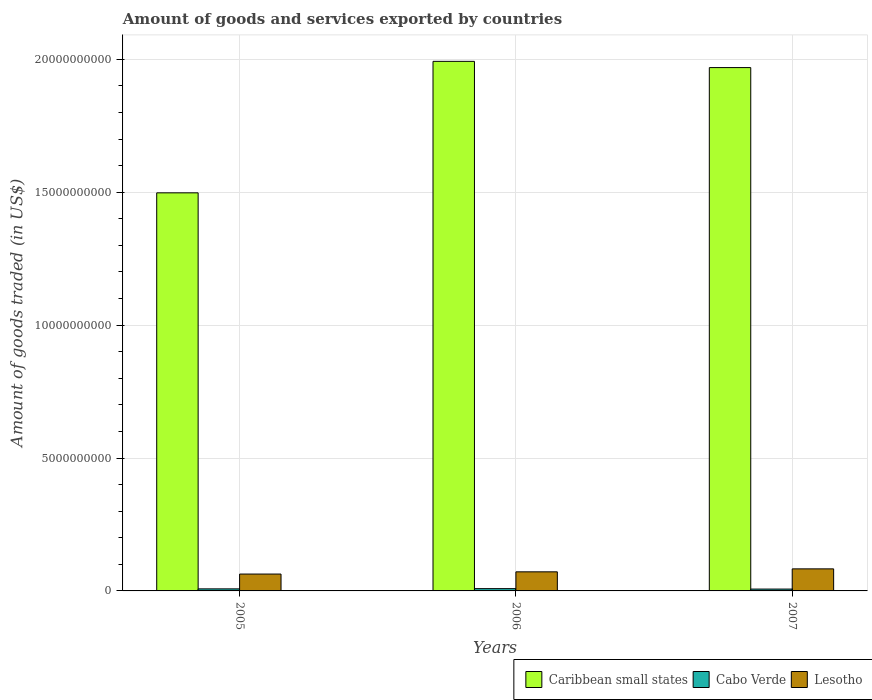How many different coloured bars are there?
Ensure brevity in your answer.  3. How many groups of bars are there?
Give a very brief answer. 3. In how many cases, is the number of bars for a given year not equal to the number of legend labels?
Your answer should be very brief. 0. What is the total amount of goods and services exported in Lesotho in 2005?
Your response must be concise. 6.34e+08. Across all years, what is the maximum total amount of goods and services exported in Lesotho?
Your answer should be compact. 8.30e+08. Across all years, what is the minimum total amount of goods and services exported in Cabo Verde?
Your answer should be compact. 6.97e+07. In which year was the total amount of goods and services exported in Lesotho maximum?
Make the answer very short. 2007. In which year was the total amount of goods and services exported in Lesotho minimum?
Your response must be concise. 2005. What is the total total amount of goods and services exported in Lesotho in the graph?
Provide a succinct answer. 2.18e+09. What is the difference between the total amount of goods and services exported in Lesotho in 2006 and that in 2007?
Your response must be concise. -1.12e+08. What is the difference between the total amount of goods and services exported in Cabo Verde in 2007 and the total amount of goods and services exported in Lesotho in 2005?
Offer a terse response. -5.65e+08. What is the average total amount of goods and services exported in Cabo Verde per year?
Your answer should be compact. 7.75e+07. In the year 2007, what is the difference between the total amount of goods and services exported in Lesotho and total amount of goods and services exported in Cabo Verde?
Provide a short and direct response. 7.60e+08. In how many years, is the total amount of goods and services exported in Lesotho greater than 11000000000 US$?
Provide a short and direct response. 0. What is the ratio of the total amount of goods and services exported in Lesotho in 2006 to that in 2007?
Your response must be concise. 0.87. Is the total amount of goods and services exported in Lesotho in 2005 less than that in 2006?
Keep it short and to the point. Yes. What is the difference between the highest and the second highest total amount of goods and services exported in Lesotho?
Make the answer very short. 1.12e+08. What is the difference between the highest and the lowest total amount of goods and services exported in Cabo Verde?
Keep it short and to the point. 1.61e+07. In how many years, is the total amount of goods and services exported in Caribbean small states greater than the average total amount of goods and services exported in Caribbean small states taken over all years?
Your answer should be compact. 2. Is the sum of the total amount of goods and services exported in Cabo Verde in 2006 and 2007 greater than the maximum total amount of goods and services exported in Caribbean small states across all years?
Offer a very short reply. No. What does the 3rd bar from the left in 2006 represents?
Keep it short and to the point. Lesotho. What does the 3rd bar from the right in 2007 represents?
Give a very brief answer. Caribbean small states. How many bars are there?
Make the answer very short. 9. Are all the bars in the graph horizontal?
Ensure brevity in your answer.  No. How many years are there in the graph?
Keep it short and to the point. 3. Are the values on the major ticks of Y-axis written in scientific E-notation?
Provide a short and direct response. No. Does the graph contain any zero values?
Provide a short and direct response. No. Where does the legend appear in the graph?
Your answer should be compact. Bottom right. How are the legend labels stacked?
Offer a terse response. Horizontal. What is the title of the graph?
Your answer should be compact. Amount of goods and services exported by countries. Does "Angola" appear as one of the legend labels in the graph?
Ensure brevity in your answer.  No. What is the label or title of the Y-axis?
Provide a short and direct response. Amount of goods traded (in US$). What is the Amount of goods traded (in US$) of Caribbean small states in 2005?
Give a very brief answer. 1.50e+1. What is the Amount of goods traded (in US$) of Cabo Verde in 2005?
Keep it short and to the point. 7.71e+07. What is the Amount of goods traded (in US$) in Lesotho in 2005?
Offer a very short reply. 6.34e+08. What is the Amount of goods traded (in US$) in Caribbean small states in 2006?
Your answer should be very brief. 1.99e+1. What is the Amount of goods traded (in US$) of Cabo Verde in 2006?
Your response must be concise. 8.58e+07. What is the Amount of goods traded (in US$) of Lesotho in 2006?
Ensure brevity in your answer.  7.18e+08. What is the Amount of goods traded (in US$) in Caribbean small states in 2007?
Ensure brevity in your answer.  1.97e+1. What is the Amount of goods traded (in US$) in Cabo Verde in 2007?
Your answer should be very brief. 6.97e+07. What is the Amount of goods traded (in US$) in Lesotho in 2007?
Your response must be concise. 8.30e+08. Across all years, what is the maximum Amount of goods traded (in US$) of Caribbean small states?
Provide a succinct answer. 1.99e+1. Across all years, what is the maximum Amount of goods traded (in US$) in Cabo Verde?
Your answer should be compact. 8.58e+07. Across all years, what is the maximum Amount of goods traded (in US$) of Lesotho?
Provide a short and direct response. 8.30e+08. Across all years, what is the minimum Amount of goods traded (in US$) of Caribbean small states?
Offer a very short reply. 1.50e+1. Across all years, what is the minimum Amount of goods traded (in US$) of Cabo Verde?
Ensure brevity in your answer.  6.97e+07. Across all years, what is the minimum Amount of goods traded (in US$) of Lesotho?
Offer a very short reply. 6.34e+08. What is the total Amount of goods traded (in US$) of Caribbean small states in the graph?
Provide a succinct answer. 5.46e+1. What is the total Amount of goods traded (in US$) of Cabo Verde in the graph?
Offer a terse response. 2.33e+08. What is the total Amount of goods traded (in US$) in Lesotho in the graph?
Your answer should be very brief. 2.18e+09. What is the difference between the Amount of goods traded (in US$) of Caribbean small states in 2005 and that in 2006?
Make the answer very short. -4.95e+09. What is the difference between the Amount of goods traded (in US$) in Cabo Verde in 2005 and that in 2006?
Provide a succinct answer. -8.69e+06. What is the difference between the Amount of goods traded (in US$) of Lesotho in 2005 and that in 2006?
Offer a very short reply. -8.39e+07. What is the difference between the Amount of goods traded (in US$) in Caribbean small states in 2005 and that in 2007?
Provide a succinct answer. -4.71e+09. What is the difference between the Amount of goods traded (in US$) of Cabo Verde in 2005 and that in 2007?
Provide a succinct answer. 7.46e+06. What is the difference between the Amount of goods traded (in US$) of Lesotho in 2005 and that in 2007?
Make the answer very short. -1.95e+08. What is the difference between the Amount of goods traded (in US$) of Caribbean small states in 2006 and that in 2007?
Ensure brevity in your answer.  2.35e+08. What is the difference between the Amount of goods traded (in US$) in Cabo Verde in 2006 and that in 2007?
Give a very brief answer. 1.61e+07. What is the difference between the Amount of goods traded (in US$) in Lesotho in 2006 and that in 2007?
Provide a succinct answer. -1.12e+08. What is the difference between the Amount of goods traded (in US$) in Caribbean small states in 2005 and the Amount of goods traded (in US$) in Cabo Verde in 2006?
Your answer should be very brief. 1.49e+1. What is the difference between the Amount of goods traded (in US$) of Caribbean small states in 2005 and the Amount of goods traded (in US$) of Lesotho in 2006?
Your response must be concise. 1.43e+1. What is the difference between the Amount of goods traded (in US$) in Cabo Verde in 2005 and the Amount of goods traded (in US$) in Lesotho in 2006?
Make the answer very short. -6.41e+08. What is the difference between the Amount of goods traded (in US$) in Caribbean small states in 2005 and the Amount of goods traded (in US$) in Cabo Verde in 2007?
Offer a very short reply. 1.49e+1. What is the difference between the Amount of goods traded (in US$) in Caribbean small states in 2005 and the Amount of goods traded (in US$) in Lesotho in 2007?
Make the answer very short. 1.41e+1. What is the difference between the Amount of goods traded (in US$) in Cabo Verde in 2005 and the Amount of goods traded (in US$) in Lesotho in 2007?
Keep it short and to the point. -7.53e+08. What is the difference between the Amount of goods traded (in US$) of Caribbean small states in 2006 and the Amount of goods traded (in US$) of Cabo Verde in 2007?
Your response must be concise. 1.99e+1. What is the difference between the Amount of goods traded (in US$) in Caribbean small states in 2006 and the Amount of goods traded (in US$) in Lesotho in 2007?
Your response must be concise. 1.91e+1. What is the difference between the Amount of goods traded (in US$) of Cabo Verde in 2006 and the Amount of goods traded (in US$) of Lesotho in 2007?
Keep it short and to the point. -7.44e+08. What is the average Amount of goods traded (in US$) of Caribbean small states per year?
Ensure brevity in your answer.  1.82e+1. What is the average Amount of goods traded (in US$) of Cabo Verde per year?
Your answer should be compact. 7.75e+07. What is the average Amount of goods traded (in US$) of Lesotho per year?
Give a very brief answer. 7.27e+08. In the year 2005, what is the difference between the Amount of goods traded (in US$) in Caribbean small states and Amount of goods traded (in US$) in Cabo Verde?
Provide a succinct answer. 1.49e+1. In the year 2005, what is the difference between the Amount of goods traded (in US$) in Caribbean small states and Amount of goods traded (in US$) in Lesotho?
Make the answer very short. 1.43e+1. In the year 2005, what is the difference between the Amount of goods traded (in US$) in Cabo Verde and Amount of goods traded (in US$) in Lesotho?
Provide a succinct answer. -5.57e+08. In the year 2006, what is the difference between the Amount of goods traded (in US$) of Caribbean small states and Amount of goods traded (in US$) of Cabo Verde?
Offer a terse response. 1.98e+1. In the year 2006, what is the difference between the Amount of goods traded (in US$) in Caribbean small states and Amount of goods traded (in US$) in Lesotho?
Your answer should be very brief. 1.92e+1. In the year 2006, what is the difference between the Amount of goods traded (in US$) in Cabo Verde and Amount of goods traded (in US$) in Lesotho?
Offer a very short reply. -6.32e+08. In the year 2007, what is the difference between the Amount of goods traded (in US$) in Caribbean small states and Amount of goods traded (in US$) in Cabo Verde?
Your answer should be very brief. 1.96e+1. In the year 2007, what is the difference between the Amount of goods traded (in US$) in Caribbean small states and Amount of goods traded (in US$) in Lesotho?
Provide a succinct answer. 1.89e+1. In the year 2007, what is the difference between the Amount of goods traded (in US$) of Cabo Verde and Amount of goods traded (in US$) of Lesotho?
Make the answer very short. -7.60e+08. What is the ratio of the Amount of goods traded (in US$) of Caribbean small states in 2005 to that in 2006?
Provide a succinct answer. 0.75. What is the ratio of the Amount of goods traded (in US$) in Cabo Verde in 2005 to that in 2006?
Provide a short and direct response. 0.9. What is the ratio of the Amount of goods traded (in US$) in Lesotho in 2005 to that in 2006?
Give a very brief answer. 0.88. What is the ratio of the Amount of goods traded (in US$) of Caribbean small states in 2005 to that in 2007?
Your answer should be compact. 0.76. What is the ratio of the Amount of goods traded (in US$) of Cabo Verde in 2005 to that in 2007?
Ensure brevity in your answer.  1.11. What is the ratio of the Amount of goods traded (in US$) in Lesotho in 2005 to that in 2007?
Your answer should be very brief. 0.76. What is the ratio of the Amount of goods traded (in US$) of Caribbean small states in 2006 to that in 2007?
Give a very brief answer. 1.01. What is the ratio of the Amount of goods traded (in US$) in Cabo Verde in 2006 to that in 2007?
Provide a succinct answer. 1.23. What is the ratio of the Amount of goods traded (in US$) of Lesotho in 2006 to that in 2007?
Your response must be concise. 0.87. What is the difference between the highest and the second highest Amount of goods traded (in US$) of Caribbean small states?
Make the answer very short. 2.35e+08. What is the difference between the highest and the second highest Amount of goods traded (in US$) of Cabo Verde?
Keep it short and to the point. 8.69e+06. What is the difference between the highest and the second highest Amount of goods traded (in US$) of Lesotho?
Offer a very short reply. 1.12e+08. What is the difference between the highest and the lowest Amount of goods traded (in US$) in Caribbean small states?
Your answer should be very brief. 4.95e+09. What is the difference between the highest and the lowest Amount of goods traded (in US$) in Cabo Verde?
Offer a terse response. 1.61e+07. What is the difference between the highest and the lowest Amount of goods traded (in US$) of Lesotho?
Give a very brief answer. 1.95e+08. 